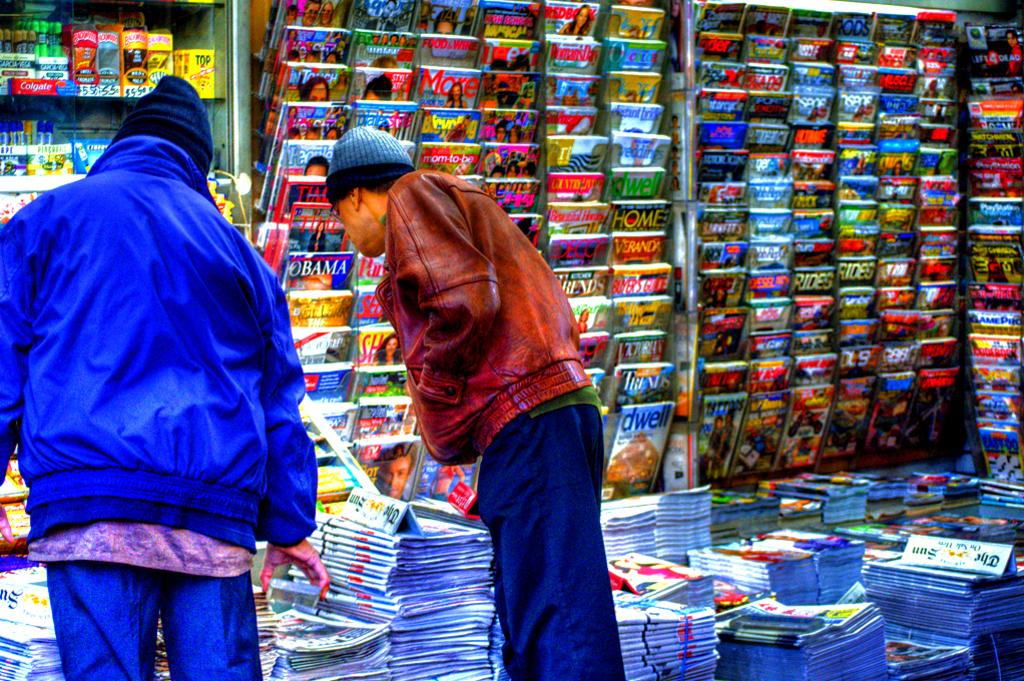<image>
Share a concise interpretation of the image provided. Two men looking in a sundry shop that sells Colgate toothpaste. 